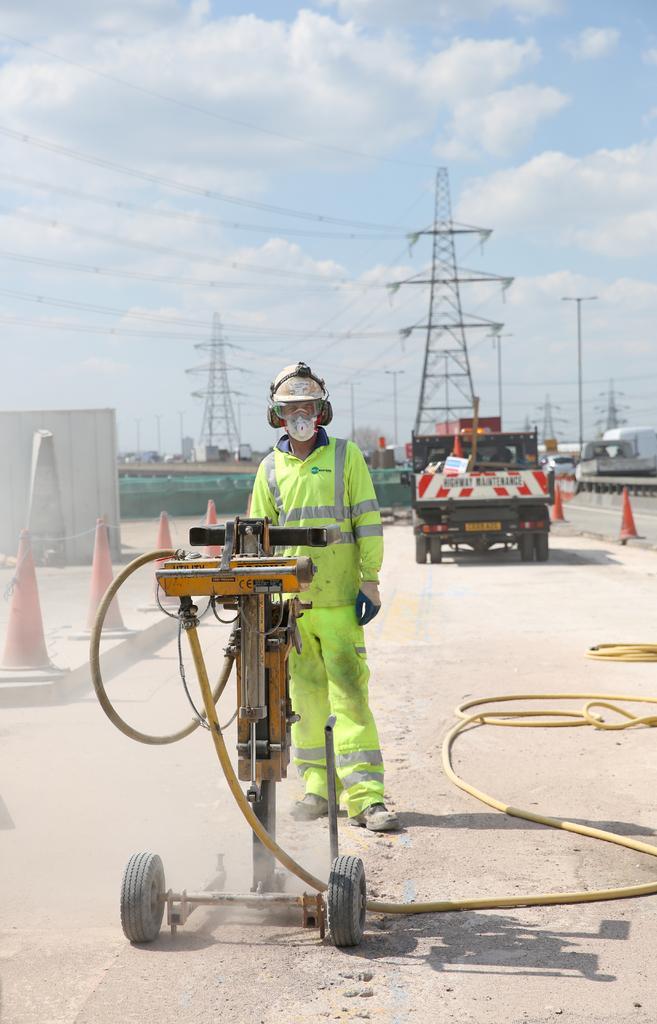Describe this image in one or two sentences. In this image in the center there is one person standing, and there is some machine and mike. And in the background there are some barricades, vehicles, towers, poles and some other objects. At the bottom there is road, and at the top of the image there is sky and also i can see some wires. 